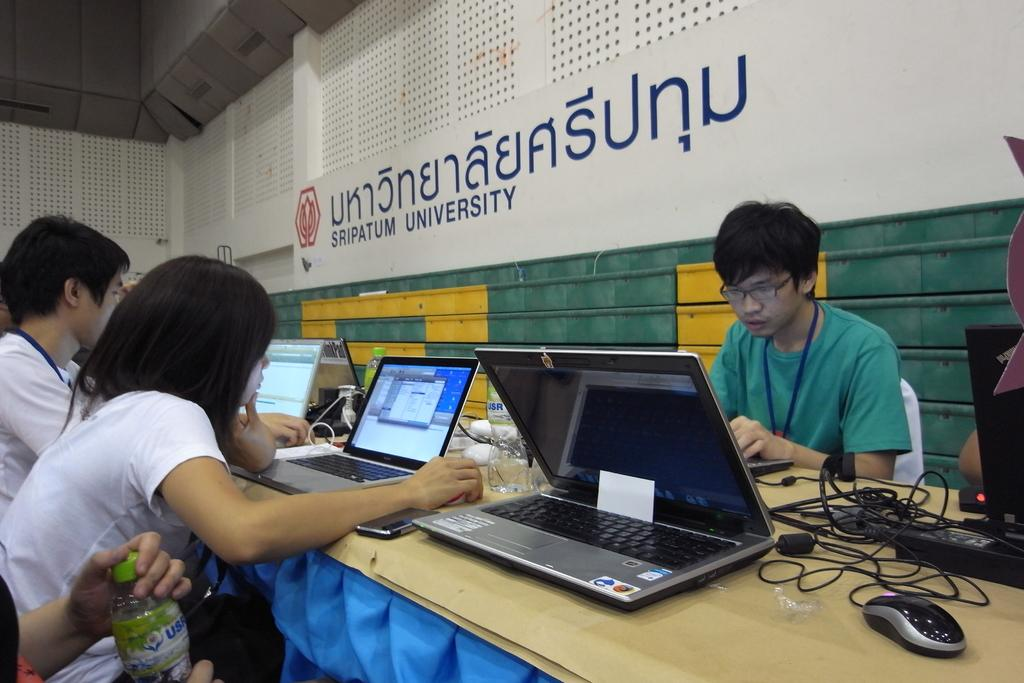<image>
Give a short and clear explanation of the subsequent image. People work at a table below a sign for sripatum university. 